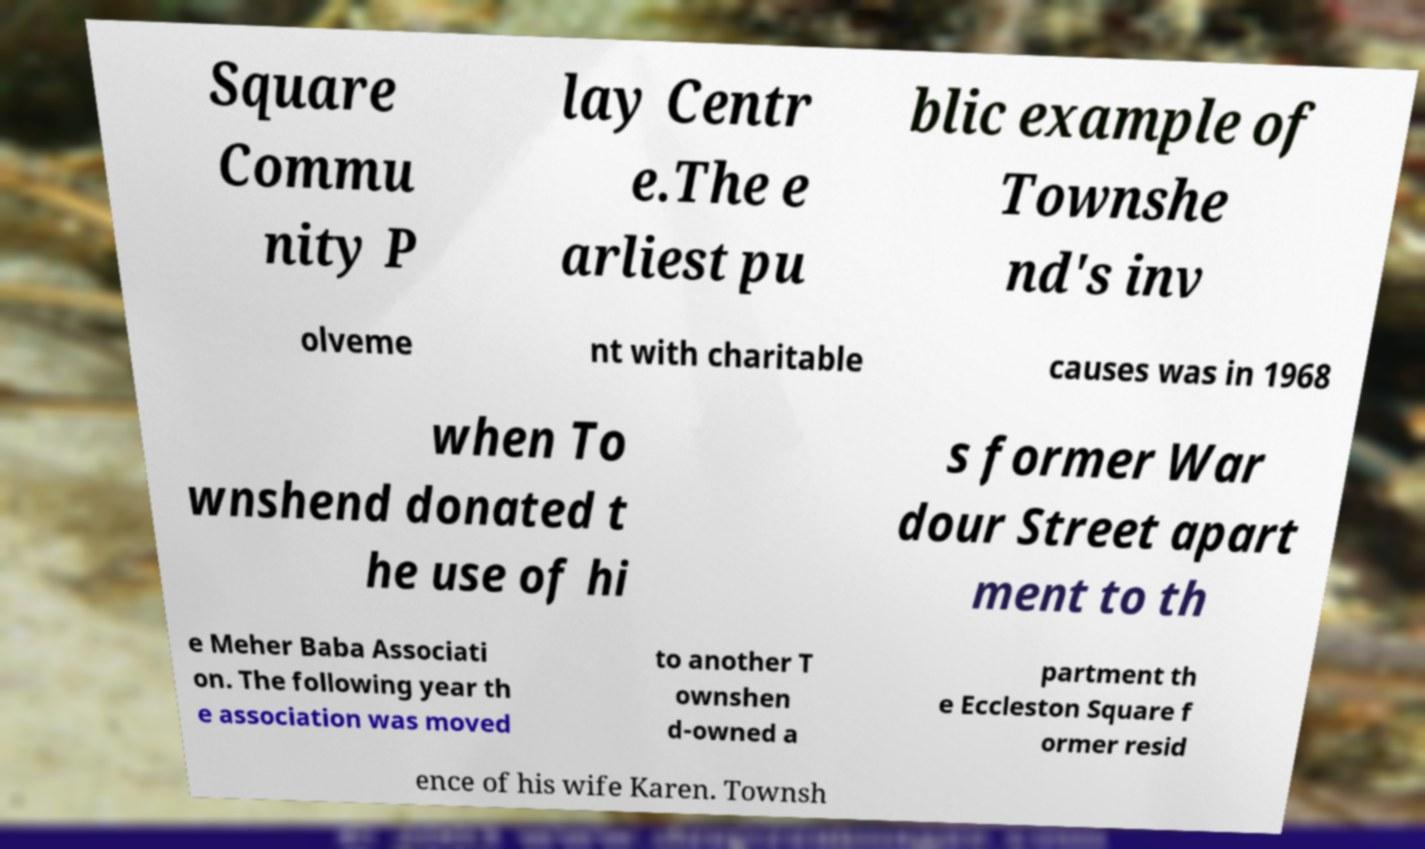Please identify and transcribe the text found in this image. Square Commu nity P lay Centr e.The e arliest pu blic example of Townshe nd's inv olveme nt with charitable causes was in 1968 when To wnshend donated t he use of hi s former War dour Street apart ment to th e Meher Baba Associati on. The following year th e association was moved to another T ownshen d-owned a partment th e Eccleston Square f ormer resid ence of his wife Karen. Townsh 